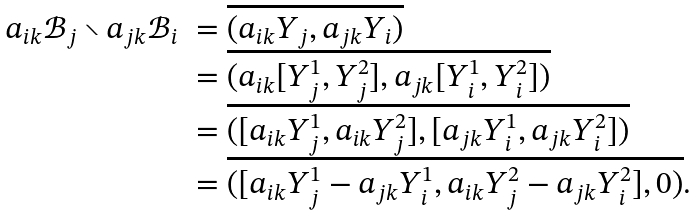Convert formula to latex. <formula><loc_0><loc_0><loc_500><loc_500>\begin{array} { l l } a _ { i k } \mathcal { B } _ { j } \smallsetminus a _ { j k } \mathcal { B } _ { i } & = \overline { ( a _ { i k } Y _ { j } , a _ { j k } Y _ { i } ) } \\ & = \overline { ( a _ { i k } [ Y _ { j } ^ { 1 } , Y _ { j } ^ { 2 } ] , a _ { j k } [ Y _ { i } ^ { 1 } , Y _ { i } ^ { 2 } ] ) } \\ & = \overline { ( [ a _ { i k } Y _ { j } ^ { 1 } , a _ { i k } Y _ { j } ^ { 2 } ] , [ a _ { j k } Y _ { i } ^ { 1 } , a _ { j k } Y _ { i } ^ { 2 } ] ) } \\ & = \overline { ( [ a _ { i k } Y _ { j } ^ { 1 } - a _ { j k } Y _ { i } ^ { 1 } , a _ { i k } Y _ { j } ^ { 2 } - a _ { j k } Y _ { i } ^ { 2 } ] , 0 ) } . \end{array}</formula> 